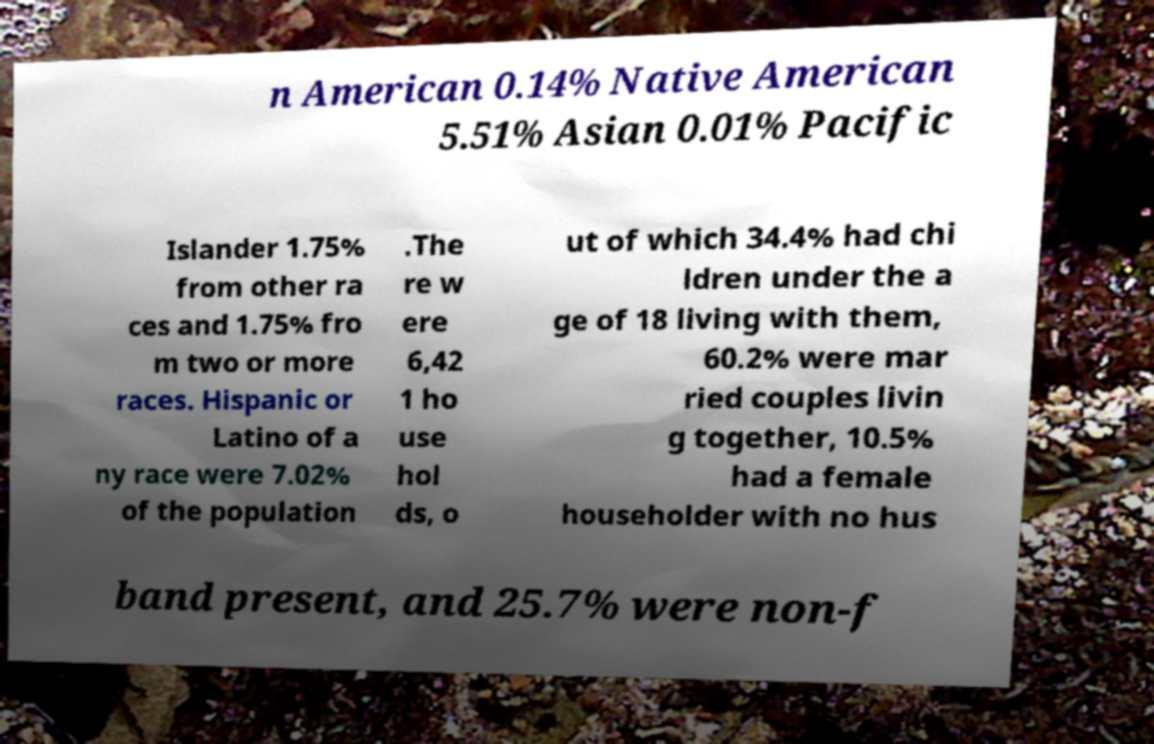Could you extract and type out the text from this image? n American 0.14% Native American 5.51% Asian 0.01% Pacific Islander 1.75% from other ra ces and 1.75% fro m two or more races. Hispanic or Latino of a ny race were 7.02% of the population .The re w ere 6,42 1 ho use hol ds, o ut of which 34.4% had chi ldren under the a ge of 18 living with them, 60.2% were mar ried couples livin g together, 10.5% had a female householder with no hus band present, and 25.7% were non-f 